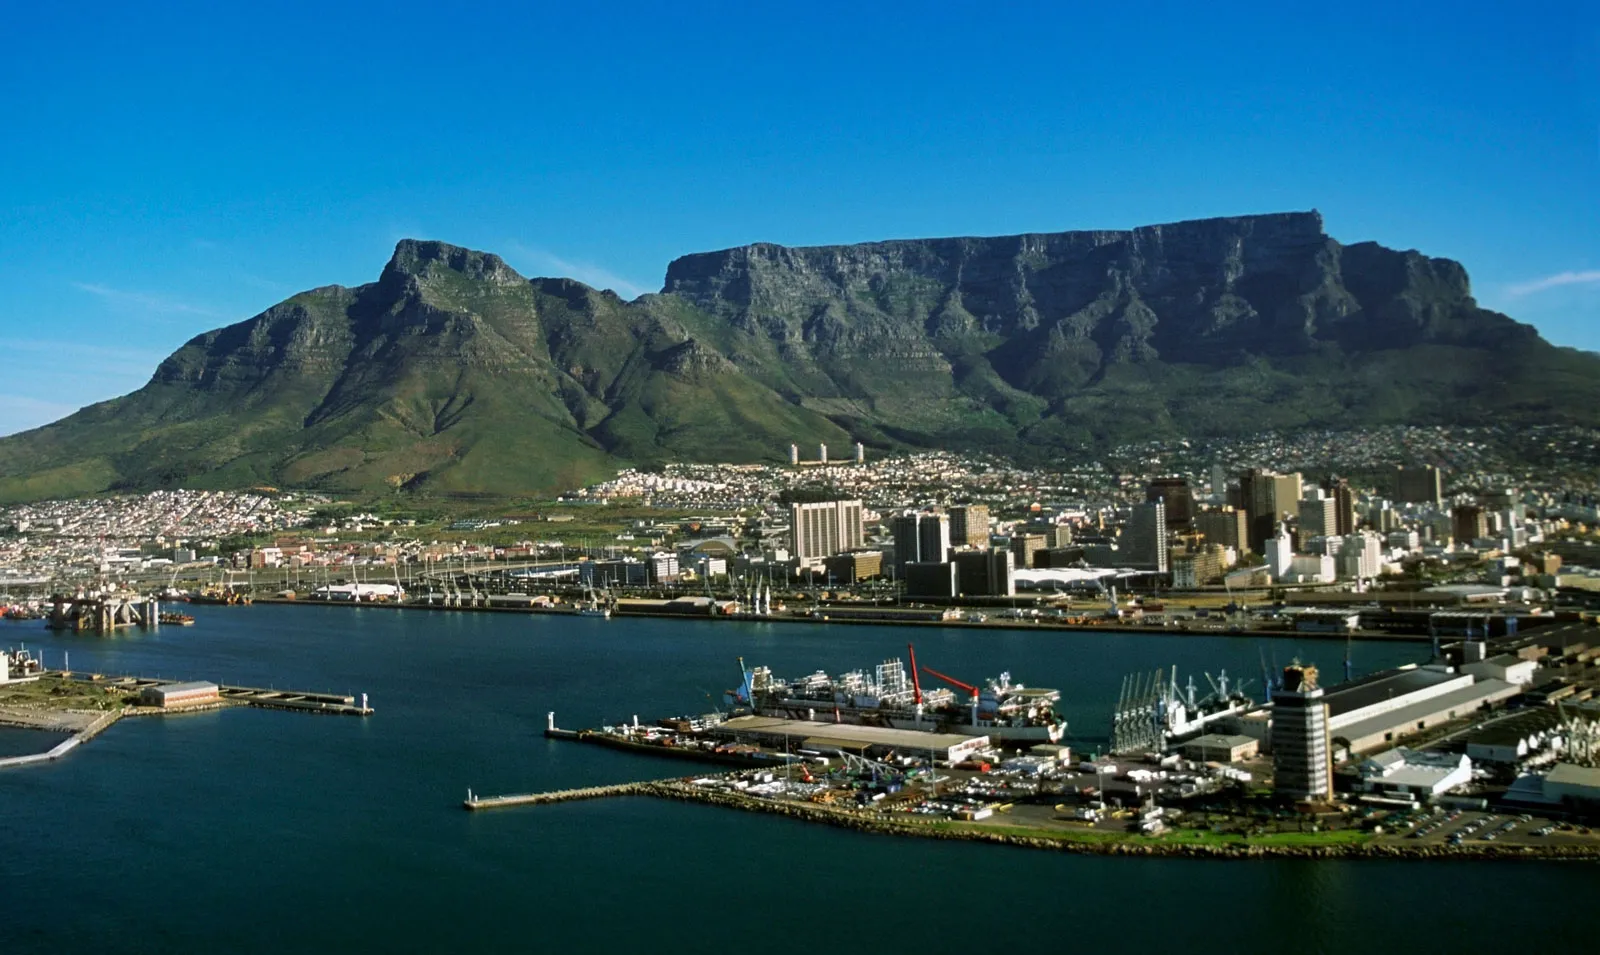Can you describe any historical significance of the mountain seen in the image? Table Mountain, a central feature in this image, is not only famous for its stunning views but also for its historical significance. It has been a guiding beacon for sailors for centuries, commonly known as the 'Tavern of the Seas' during the Age of Exploration. The mountain and its surroundings are rich in biodiversity and are home to unique flora and fauna, many of which are endemic and cannot be found anywhere else in the world. It's also significant in local lore and culture, often featured in stories and serving as a symbol of the city's identity. 